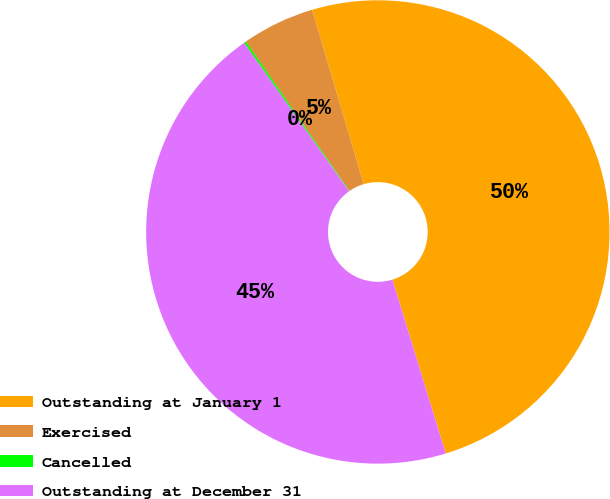<chart> <loc_0><loc_0><loc_500><loc_500><pie_chart><fcel>Outstanding at January 1<fcel>Exercised<fcel>Cancelled<fcel>Outstanding at December 31<nl><fcel>49.85%<fcel>5.07%<fcel>0.15%<fcel>44.93%<nl></chart> 